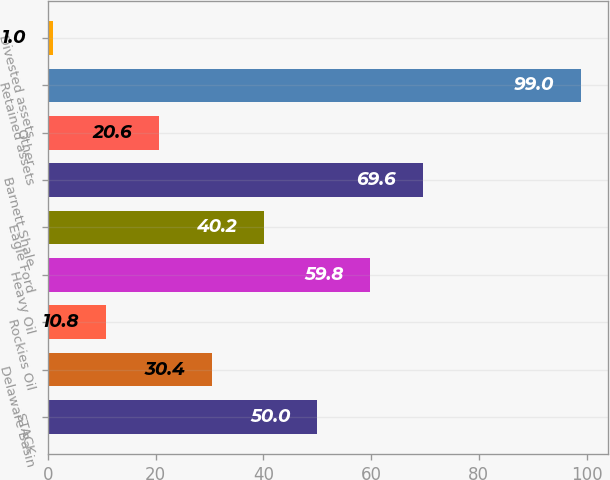Convert chart to OTSL. <chart><loc_0><loc_0><loc_500><loc_500><bar_chart><fcel>STACK<fcel>Delaware Basin<fcel>Rockies Oil<fcel>Heavy Oil<fcel>Eagle Ford<fcel>Barnett Shale<fcel>Other<fcel>Retained assets<fcel>Divested assets<nl><fcel>50<fcel>30.4<fcel>10.8<fcel>59.8<fcel>40.2<fcel>69.6<fcel>20.6<fcel>99<fcel>1<nl></chart> 